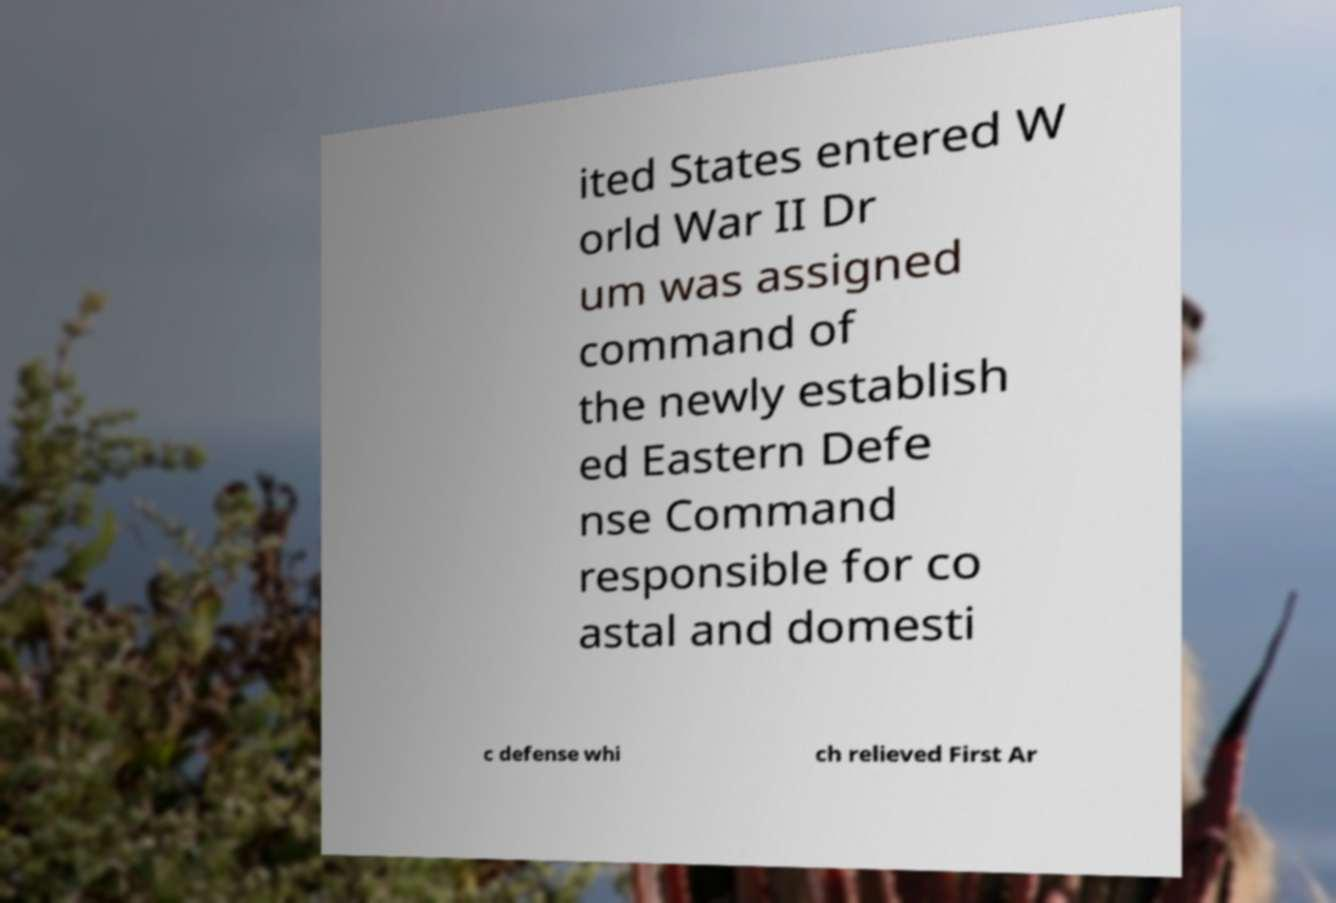Please read and relay the text visible in this image. What does it say? ited States entered W orld War II Dr um was assigned command of the newly establish ed Eastern Defe nse Command responsible for co astal and domesti c defense whi ch relieved First Ar 